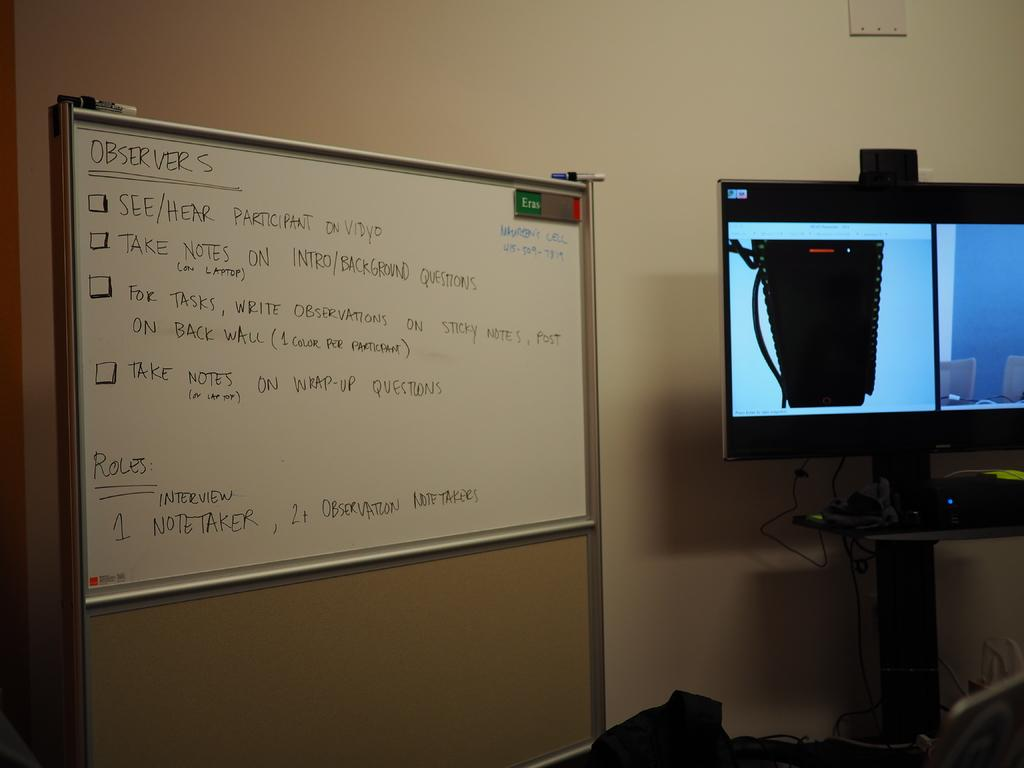Provide a one-sentence caption for the provided image. A white marker board has the word observers on top of a list. 